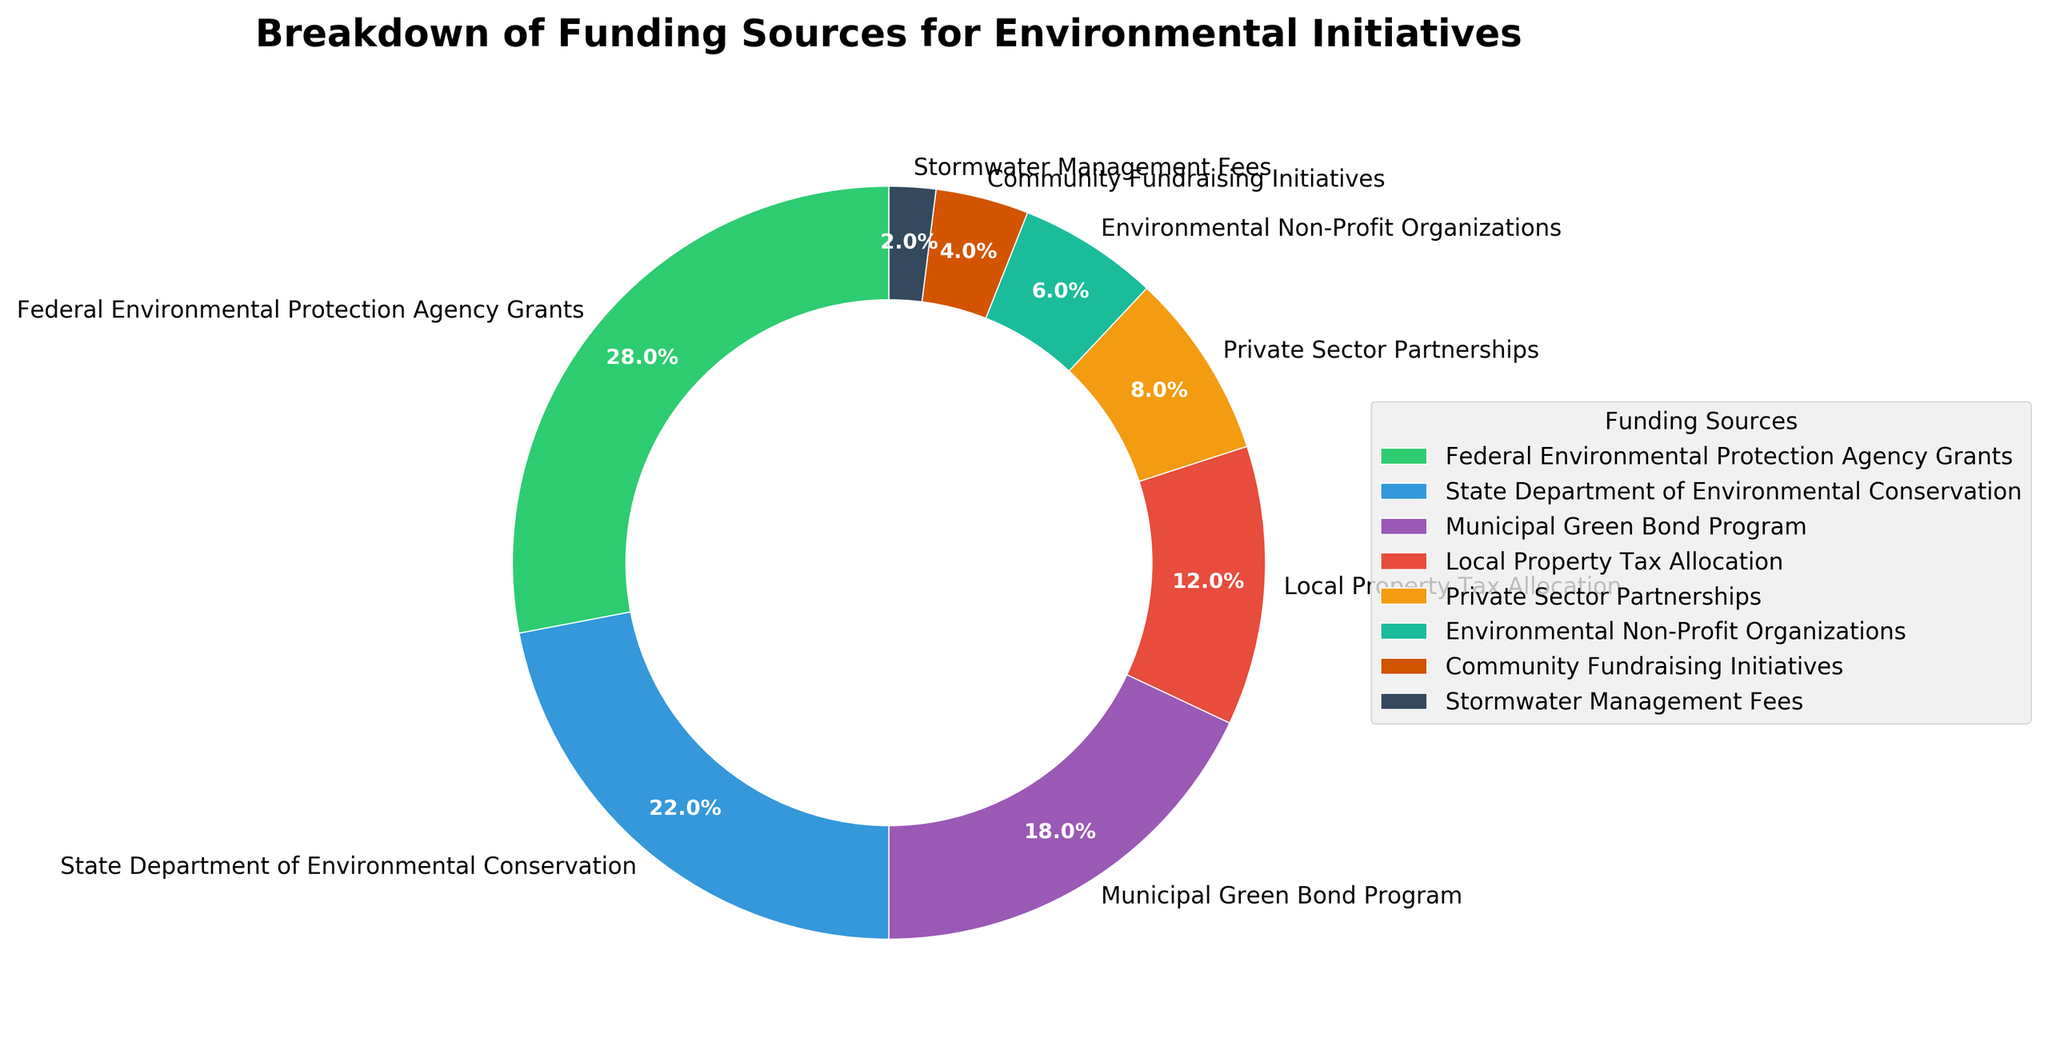What's the largest funding source for environmental initiatives? The largest funding source can be determined by looking at the segment with the highest percentage in the pie chart; in this case, it's labeled as Federal Environmental Protection Agency Grants with 28%.
Answer: Federal Environmental Protection Agency Grants What's the total contribution from Federal Environmental Protection Agency Grants and State Department of Environmental Conservation? Identify the percentages of both sources (28% and 22%) and sum them up: 28 + 22 = 50%.
Answer: 50% Which funding source has the least contribution and what percentage does it contribute? The smallest segment of the pie chart is labeled as Stormwater Management Fees with a contribution of 2%.
Answer: Stormwater Management Fees, 2% How does the contribution from Private Sector Partnerships compare to Environmental Non-Profit Organizations? Look at the segments labeled Private Sector Partnerships (8%) and Environmental Non-Profit Organizations (6%). Private Sector Partnerships contribute more by a difference of 8 - 6 = 2%.
Answer: Private Sector Partnerships contribute 2% more What is the combined percentage of the three largest funding sources? Identify the three segments with the highest percentages: Federal Environmental Protection Agency Grants (28%), State Department of Environmental Conservation (22%), and Municipal Green Bond Program (18%). Sum their contributions: 28 + 22 + 18 = 68%.
Answer: 68% What is the difference in percentage between Local Property Tax Allocation and Community Fundraising Initiatives? Identify the percentages for Local Property Tax Allocation (12%) and Community Fundraising Initiatives (4%). Calculate the difference: 12 - 4 = 8%.
Answer: 8% Which funding source is represented by a red segment and what is its percentage? By referring to the legend and the colors on the chart, the red segment corresponds to Municipal Green Bond Program with a percentage of 18%.
Answer: Municipal Green Bond Program, 18% What percentage of the funding comes from non-governmental sources? Identify the non-governmental sources: Private Sector Partnerships (8%), Environmental Non-Profit Organizations (6%), and Community Fundraising Initiatives (4%). Sum their contributions: 8 + 6 + 4 = 18%.
Answer: 18% What is the average percentage contribution of the State Department of Environmental Conservation and the Municipal Green Bond Program? Identify the percentages for State Department of Environmental Conservation (22%) and Municipal Green Bond Program (18%). Calculate the average: (22 + 18) / 2 = 20%.
Answer: 20% If an additional funding source contributed 8%, how would this compare to the existing sources? Look at the existing percentages; the new 8% funding source would be equal to Private Sector Partnerships and larger than Environmental Non-Profit Organizations, Community Fundraising Initiatives, and Stormwater Management Fees. It would be smaller than all other categories.
Answer: Equal to Private Sector Partnerships, larger than three other sources, smaller than the rest 